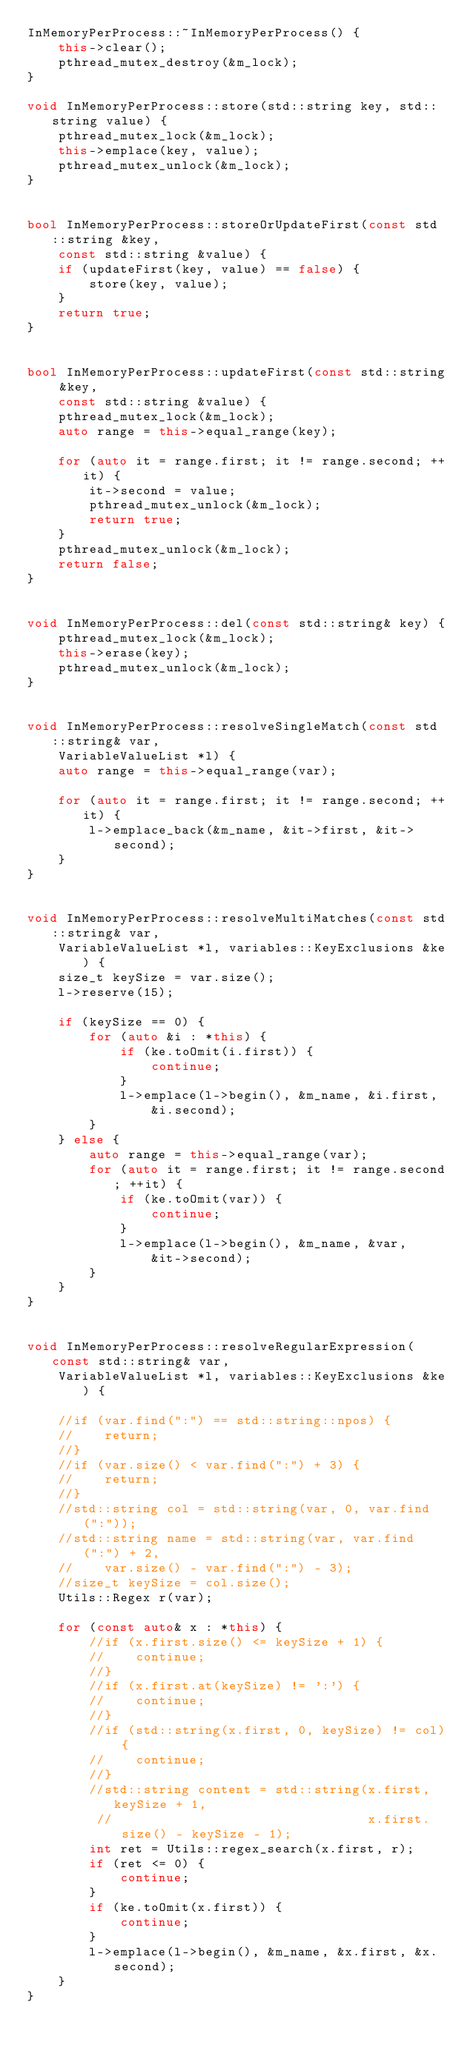<code> <loc_0><loc_0><loc_500><loc_500><_C++_>InMemoryPerProcess::~InMemoryPerProcess() {
    this->clear();
    pthread_mutex_destroy(&m_lock);
}

void InMemoryPerProcess::store(std::string key, std::string value) {
    pthread_mutex_lock(&m_lock);
    this->emplace(key, value);
    pthread_mutex_unlock(&m_lock);
}


bool InMemoryPerProcess::storeOrUpdateFirst(const std::string &key,
    const std::string &value) {
    if (updateFirst(key, value) == false) {
        store(key, value);
    }
    return true;
}


bool InMemoryPerProcess::updateFirst(const std::string &key,
    const std::string &value) {
    pthread_mutex_lock(&m_lock);
    auto range = this->equal_range(key);

    for (auto it = range.first; it != range.second; ++it) {
        it->second = value;
        pthread_mutex_unlock(&m_lock);
        return true;
    }
    pthread_mutex_unlock(&m_lock);
    return false;
}


void InMemoryPerProcess::del(const std::string& key) {
    pthread_mutex_lock(&m_lock);
    this->erase(key);
    pthread_mutex_unlock(&m_lock);
}


void InMemoryPerProcess::resolveSingleMatch(const std::string& var,
    VariableValueList *l) {
    auto range = this->equal_range(var);

    for (auto it = range.first; it != range.second; ++it) {
        l->emplace_back(&m_name, &it->first, &it->second);
    }
}


void InMemoryPerProcess::resolveMultiMatches(const std::string& var,
    VariableValueList *l, variables::KeyExclusions &ke) {
    size_t keySize = var.size();
    l->reserve(15);

    if (keySize == 0) {
        for (auto &i : *this) {
            if (ke.toOmit(i.first)) {
                continue;
            }
            l->emplace(l->begin(), &m_name, &i.first,
                &i.second);
        }
    } else {
        auto range = this->equal_range(var);
        for (auto it = range.first; it != range.second; ++it) {
            if (ke.toOmit(var)) {
                continue;
            }
            l->emplace(l->begin(), &m_name, &var,
                &it->second);
        }
    }
}


void InMemoryPerProcess::resolveRegularExpression(const std::string& var,
    VariableValueList *l, variables::KeyExclusions &ke) {

    //if (var.find(":") == std::string::npos) {
    //    return;
    //}
    //if (var.size() < var.find(":") + 3) {
    //    return;
    //}
    //std::string col = std::string(var, 0, var.find(":"));
    //std::string name = std::string(var, var.find(":") + 2,
    //    var.size() - var.find(":") - 3);
    //size_t keySize = col.size();
    Utils::Regex r(var);

    for (const auto& x : *this) {
        //if (x.first.size() <= keySize + 1) {
        //    continue;
        //}
        //if (x.first.at(keySize) != ':') {
        //    continue;
        //}
        //if (std::string(x.first, 0, keySize) != col) {
        //    continue;
        //}
        //std::string content = std::string(x.first, keySize + 1,
         //                                 x.first.size() - keySize - 1);
        int ret = Utils::regex_search(x.first, r);
        if (ret <= 0) {
            continue;
        }
        if (ke.toOmit(x.first)) {
            continue;
        }
        l->emplace(l->begin(), &m_name, &x.first, &x.second);
    }
}

</code> 